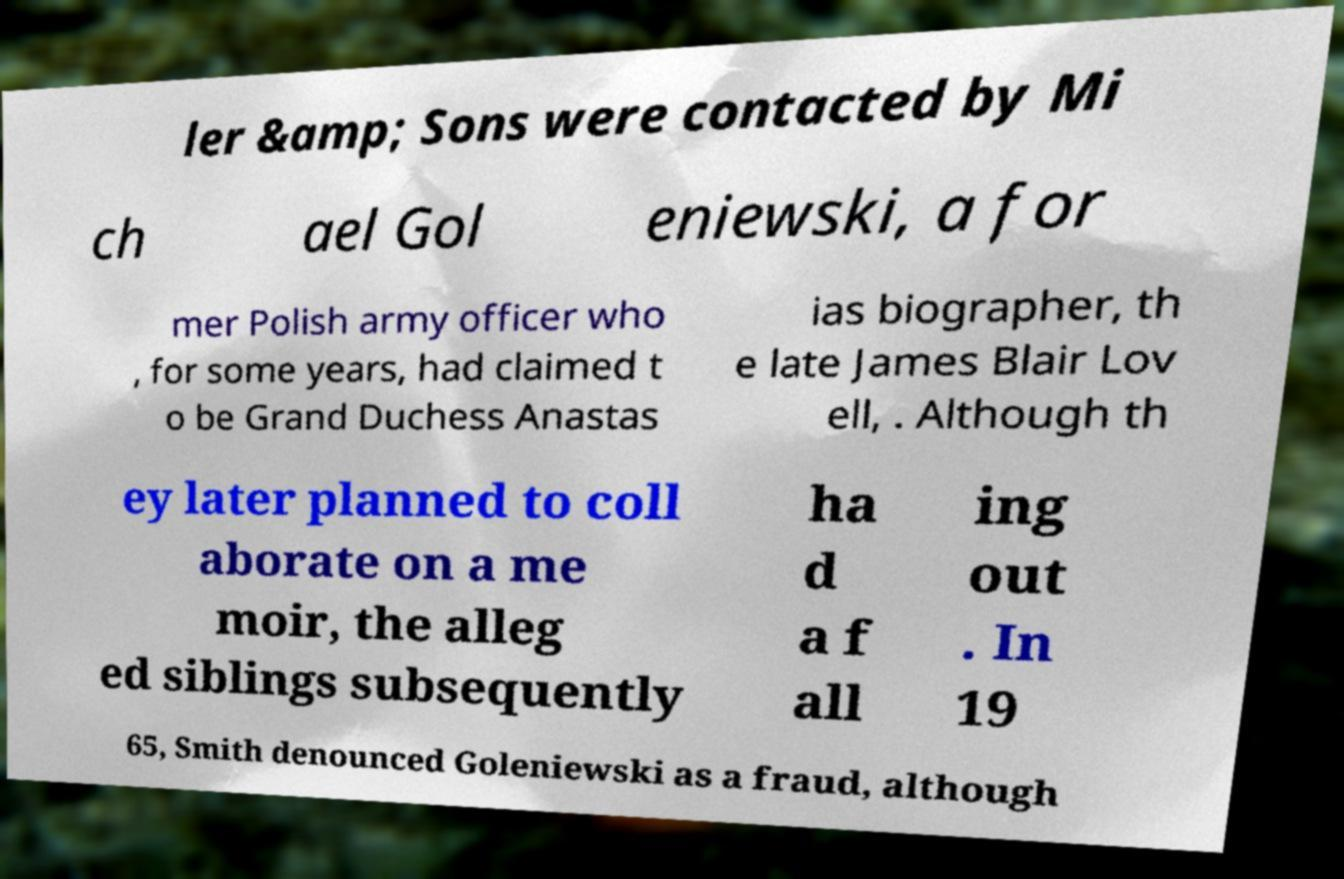What messages or text are displayed in this image? I need them in a readable, typed format. ler &amp; Sons were contacted by Mi ch ael Gol eniewski, a for mer Polish army officer who , for some years, had claimed t o be Grand Duchess Anastas ias biographer, th e late James Blair Lov ell, . Although th ey later planned to coll aborate on a me moir, the alleg ed siblings subsequently ha d a f all ing out . In 19 65, Smith denounced Goleniewski as a fraud, although 